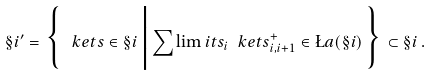Convert formula to latex. <formula><loc_0><loc_0><loc_500><loc_500>\S i ^ { \prime } = \Big \{ \, \ k e t s \in \S i \, \Big | \, { \sum \lim i t s _ { i } } \ k e t { s ^ { + } _ { i , i + 1 } } \in \L a ( \S i ) \, \Big \} \subset \S i \, .</formula> 